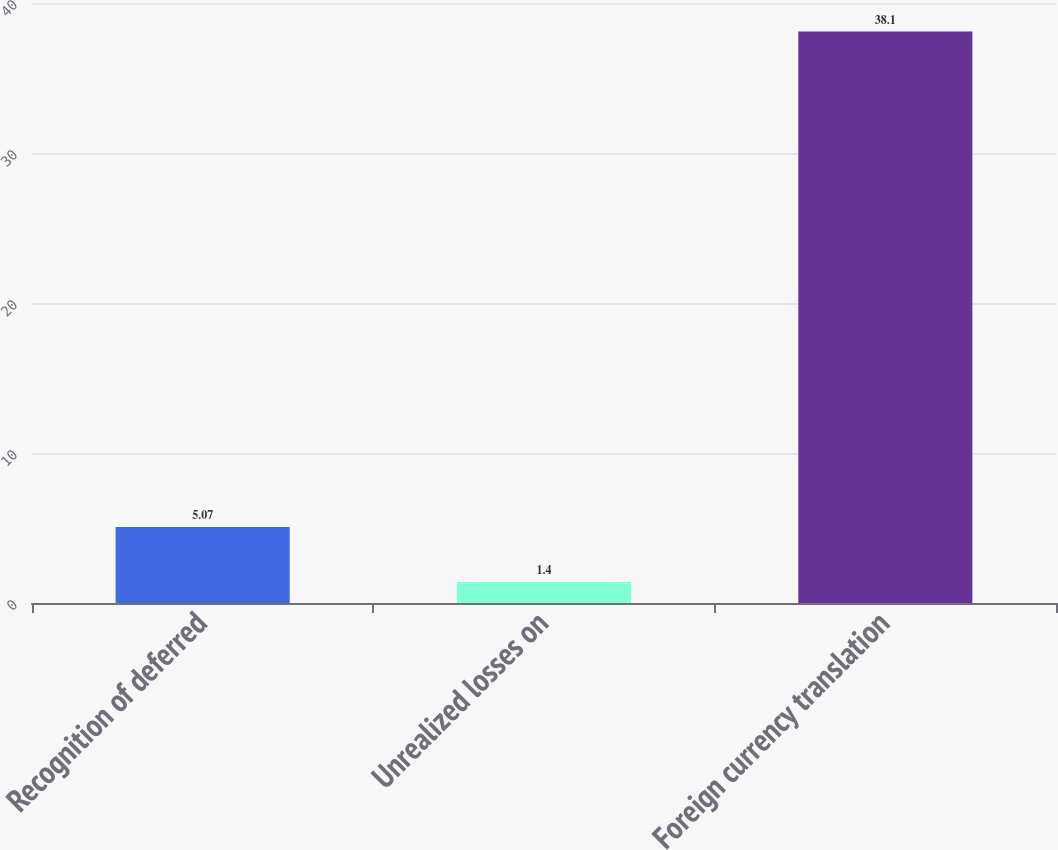Convert chart. <chart><loc_0><loc_0><loc_500><loc_500><bar_chart><fcel>Recognition of deferred<fcel>Unrealized losses on<fcel>Foreign currency translation<nl><fcel>5.07<fcel>1.4<fcel>38.1<nl></chart> 